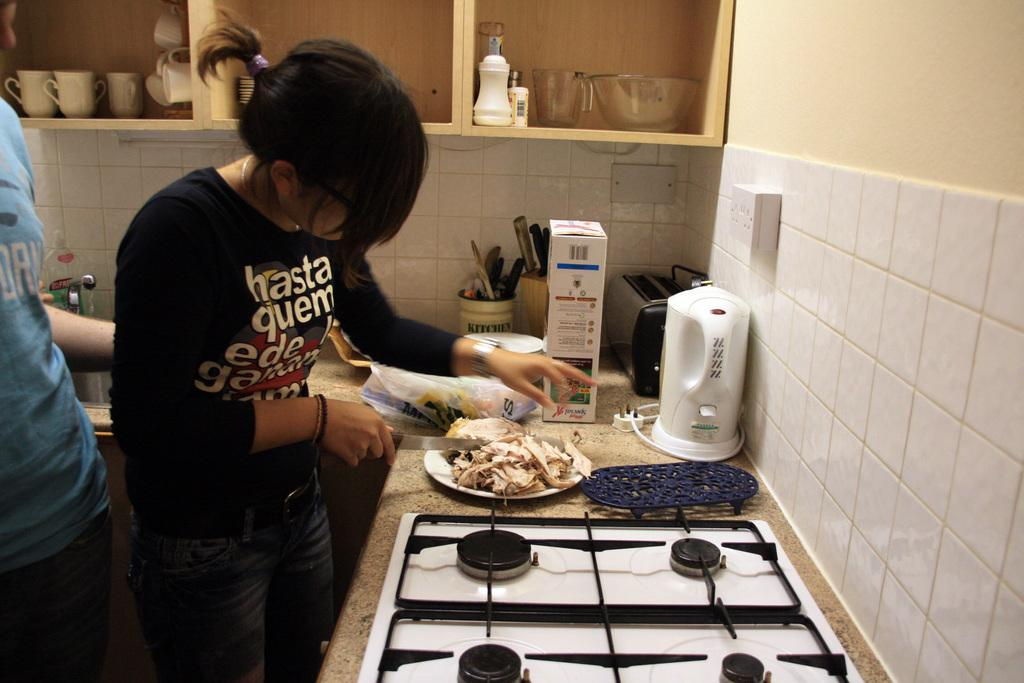<image>
Provide a brief description of the given image. A woman with Hasta Quem printed on her shirt cuts up chicken. 